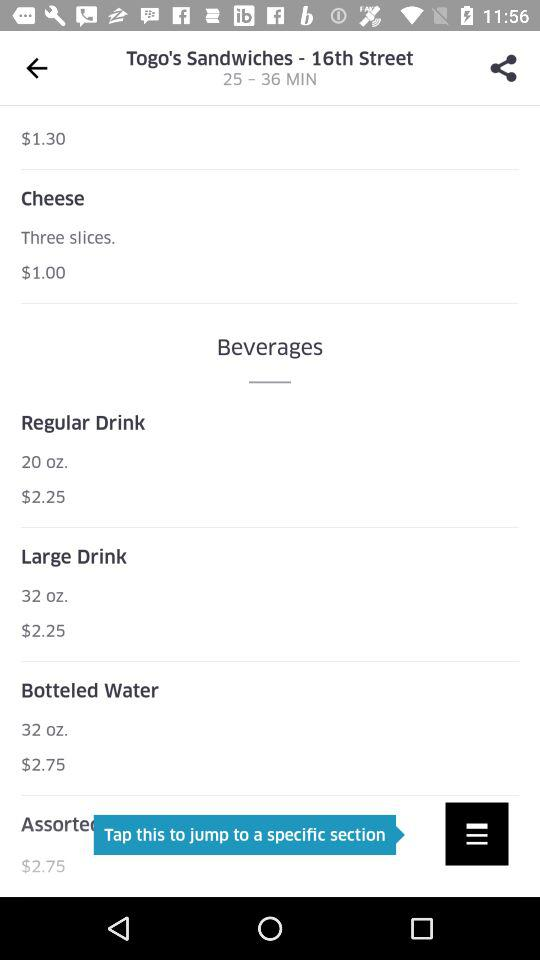How much more does a bottle of water cost than a cheese sandwich?
Answer the question using a single word or phrase. $1.75 